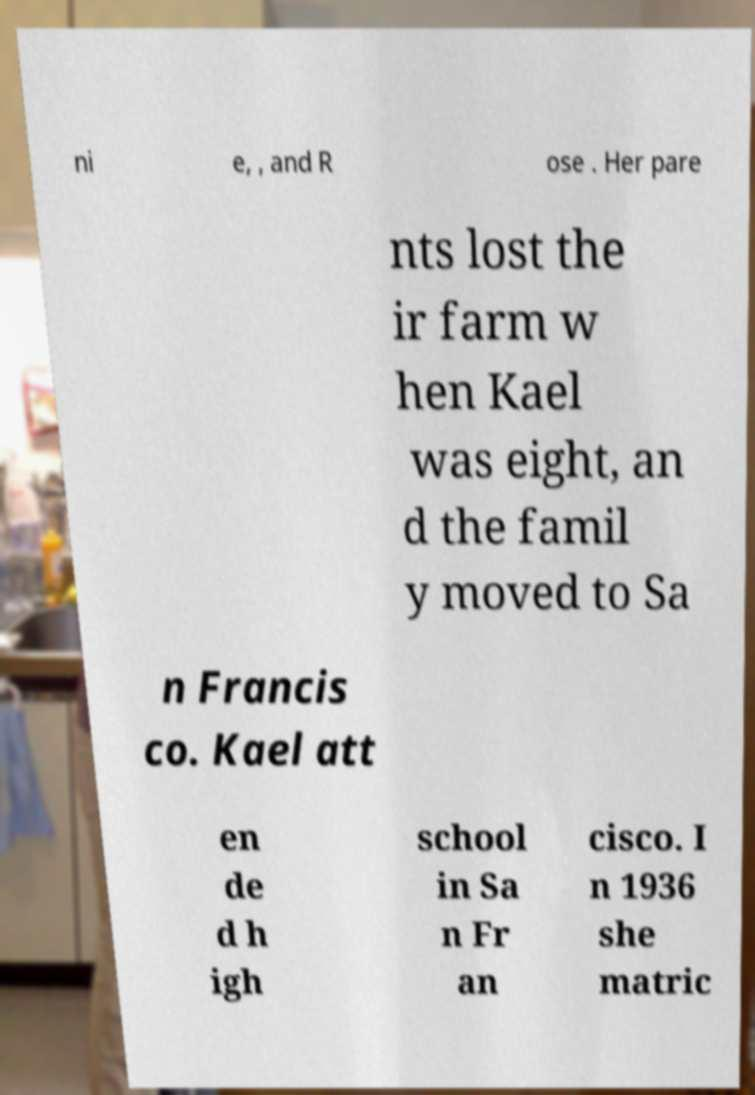Can you accurately transcribe the text from the provided image for me? ni e, , and R ose . Her pare nts lost the ir farm w hen Kael was eight, an d the famil y moved to Sa n Francis co. Kael att en de d h igh school in Sa n Fr an cisco. I n 1936 she matric 